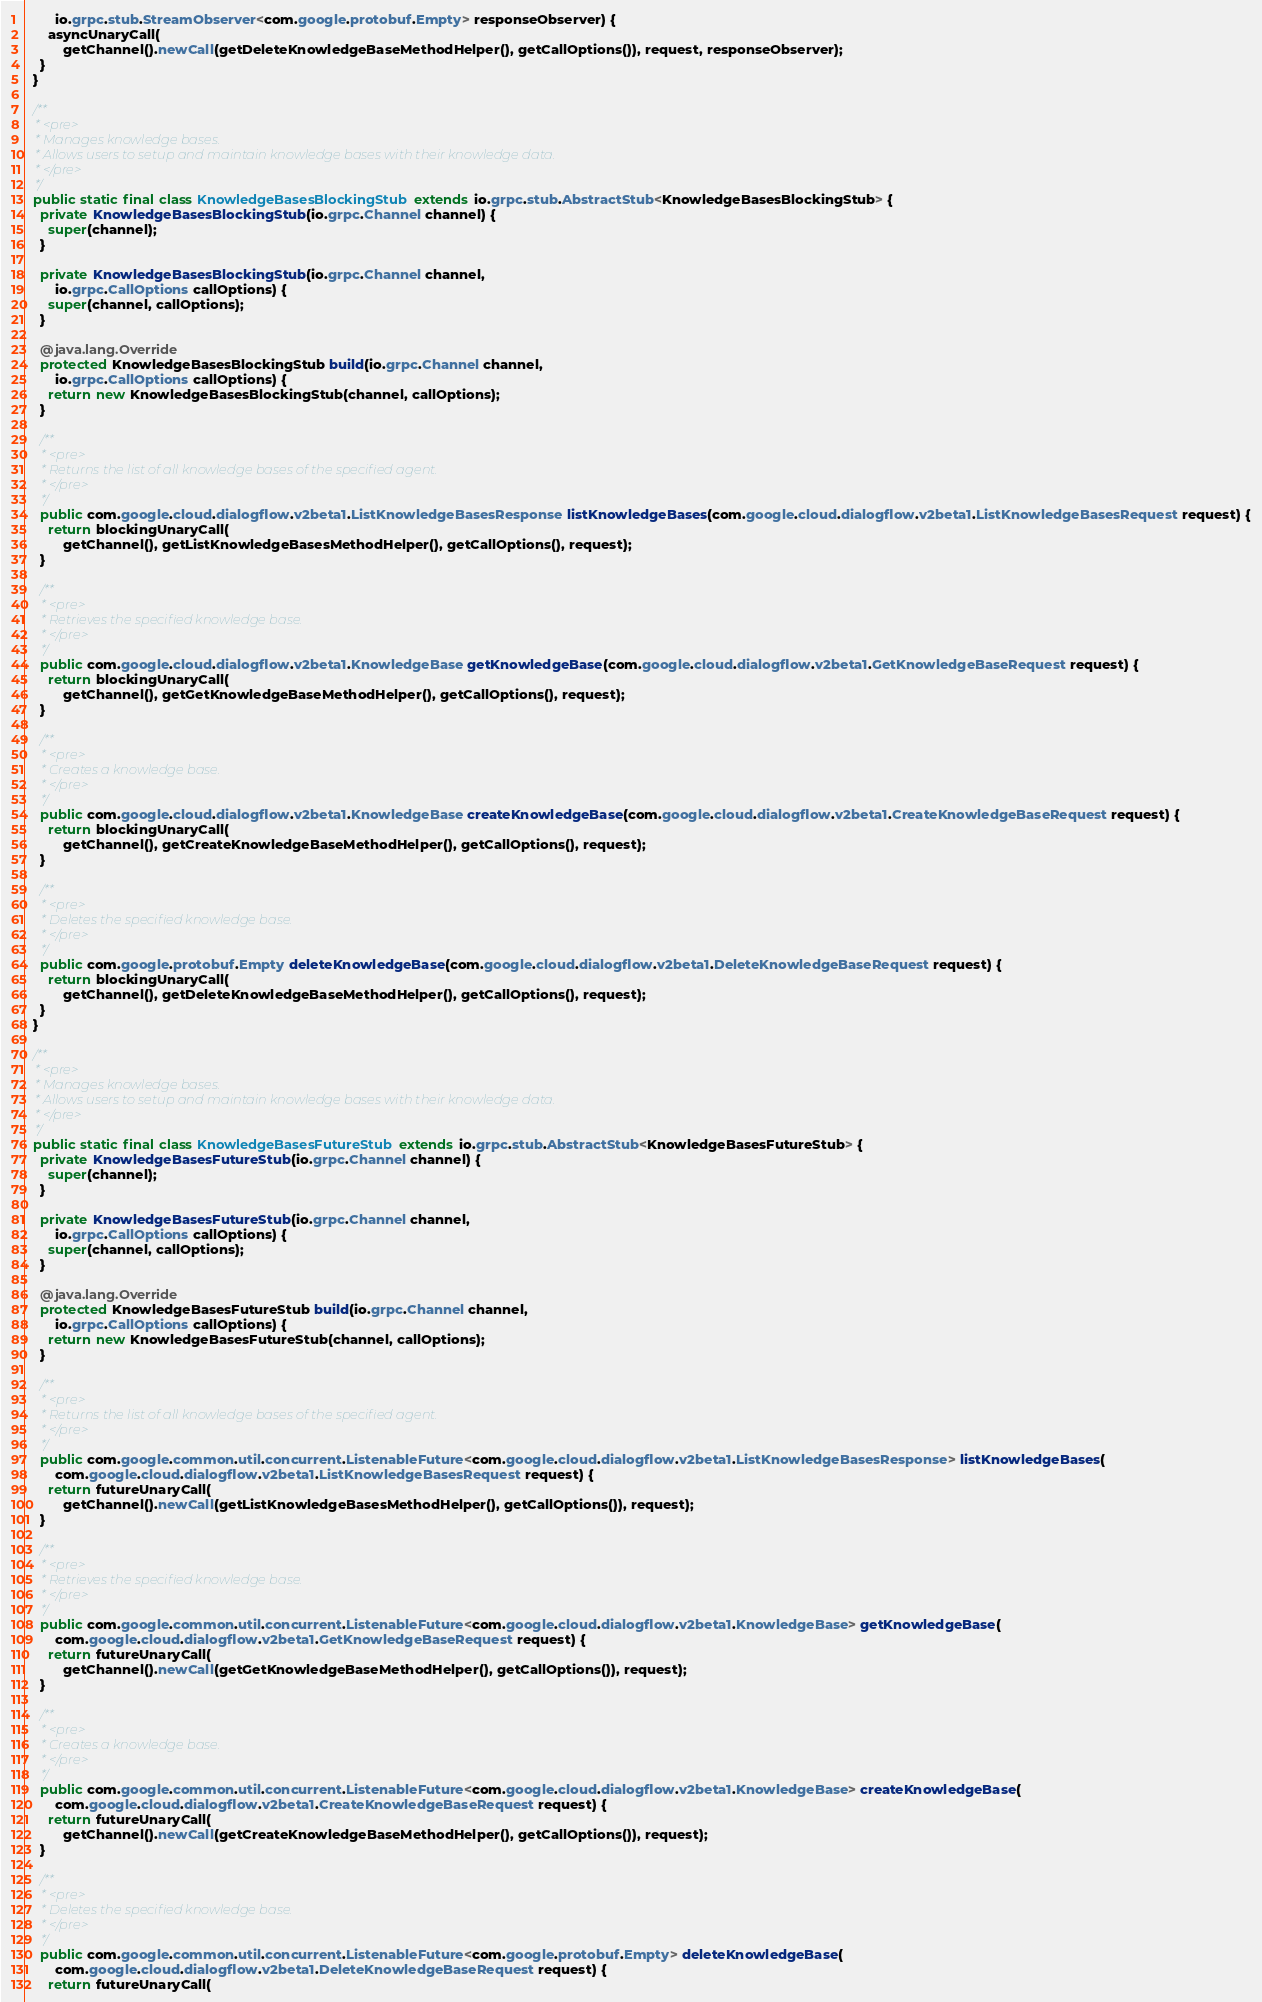<code> <loc_0><loc_0><loc_500><loc_500><_Java_>        io.grpc.stub.StreamObserver<com.google.protobuf.Empty> responseObserver) {
      asyncUnaryCall(
          getChannel().newCall(getDeleteKnowledgeBaseMethodHelper(), getCallOptions()), request, responseObserver);
    }
  }

  /**
   * <pre>
   * Manages knowledge bases.
   * Allows users to setup and maintain knowledge bases with their knowledge data.
   * </pre>
   */
  public static final class KnowledgeBasesBlockingStub extends io.grpc.stub.AbstractStub<KnowledgeBasesBlockingStub> {
    private KnowledgeBasesBlockingStub(io.grpc.Channel channel) {
      super(channel);
    }

    private KnowledgeBasesBlockingStub(io.grpc.Channel channel,
        io.grpc.CallOptions callOptions) {
      super(channel, callOptions);
    }

    @java.lang.Override
    protected KnowledgeBasesBlockingStub build(io.grpc.Channel channel,
        io.grpc.CallOptions callOptions) {
      return new KnowledgeBasesBlockingStub(channel, callOptions);
    }

    /**
     * <pre>
     * Returns the list of all knowledge bases of the specified agent.
     * </pre>
     */
    public com.google.cloud.dialogflow.v2beta1.ListKnowledgeBasesResponse listKnowledgeBases(com.google.cloud.dialogflow.v2beta1.ListKnowledgeBasesRequest request) {
      return blockingUnaryCall(
          getChannel(), getListKnowledgeBasesMethodHelper(), getCallOptions(), request);
    }

    /**
     * <pre>
     * Retrieves the specified knowledge base.
     * </pre>
     */
    public com.google.cloud.dialogflow.v2beta1.KnowledgeBase getKnowledgeBase(com.google.cloud.dialogflow.v2beta1.GetKnowledgeBaseRequest request) {
      return blockingUnaryCall(
          getChannel(), getGetKnowledgeBaseMethodHelper(), getCallOptions(), request);
    }

    /**
     * <pre>
     * Creates a knowledge base.
     * </pre>
     */
    public com.google.cloud.dialogflow.v2beta1.KnowledgeBase createKnowledgeBase(com.google.cloud.dialogflow.v2beta1.CreateKnowledgeBaseRequest request) {
      return blockingUnaryCall(
          getChannel(), getCreateKnowledgeBaseMethodHelper(), getCallOptions(), request);
    }

    /**
     * <pre>
     * Deletes the specified knowledge base.
     * </pre>
     */
    public com.google.protobuf.Empty deleteKnowledgeBase(com.google.cloud.dialogflow.v2beta1.DeleteKnowledgeBaseRequest request) {
      return blockingUnaryCall(
          getChannel(), getDeleteKnowledgeBaseMethodHelper(), getCallOptions(), request);
    }
  }

  /**
   * <pre>
   * Manages knowledge bases.
   * Allows users to setup and maintain knowledge bases with their knowledge data.
   * </pre>
   */
  public static final class KnowledgeBasesFutureStub extends io.grpc.stub.AbstractStub<KnowledgeBasesFutureStub> {
    private KnowledgeBasesFutureStub(io.grpc.Channel channel) {
      super(channel);
    }

    private KnowledgeBasesFutureStub(io.grpc.Channel channel,
        io.grpc.CallOptions callOptions) {
      super(channel, callOptions);
    }

    @java.lang.Override
    protected KnowledgeBasesFutureStub build(io.grpc.Channel channel,
        io.grpc.CallOptions callOptions) {
      return new KnowledgeBasesFutureStub(channel, callOptions);
    }

    /**
     * <pre>
     * Returns the list of all knowledge bases of the specified agent.
     * </pre>
     */
    public com.google.common.util.concurrent.ListenableFuture<com.google.cloud.dialogflow.v2beta1.ListKnowledgeBasesResponse> listKnowledgeBases(
        com.google.cloud.dialogflow.v2beta1.ListKnowledgeBasesRequest request) {
      return futureUnaryCall(
          getChannel().newCall(getListKnowledgeBasesMethodHelper(), getCallOptions()), request);
    }

    /**
     * <pre>
     * Retrieves the specified knowledge base.
     * </pre>
     */
    public com.google.common.util.concurrent.ListenableFuture<com.google.cloud.dialogflow.v2beta1.KnowledgeBase> getKnowledgeBase(
        com.google.cloud.dialogflow.v2beta1.GetKnowledgeBaseRequest request) {
      return futureUnaryCall(
          getChannel().newCall(getGetKnowledgeBaseMethodHelper(), getCallOptions()), request);
    }

    /**
     * <pre>
     * Creates a knowledge base.
     * </pre>
     */
    public com.google.common.util.concurrent.ListenableFuture<com.google.cloud.dialogflow.v2beta1.KnowledgeBase> createKnowledgeBase(
        com.google.cloud.dialogflow.v2beta1.CreateKnowledgeBaseRequest request) {
      return futureUnaryCall(
          getChannel().newCall(getCreateKnowledgeBaseMethodHelper(), getCallOptions()), request);
    }

    /**
     * <pre>
     * Deletes the specified knowledge base.
     * </pre>
     */
    public com.google.common.util.concurrent.ListenableFuture<com.google.protobuf.Empty> deleteKnowledgeBase(
        com.google.cloud.dialogflow.v2beta1.DeleteKnowledgeBaseRequest request) {
      return futureUnaryCall(</code> 